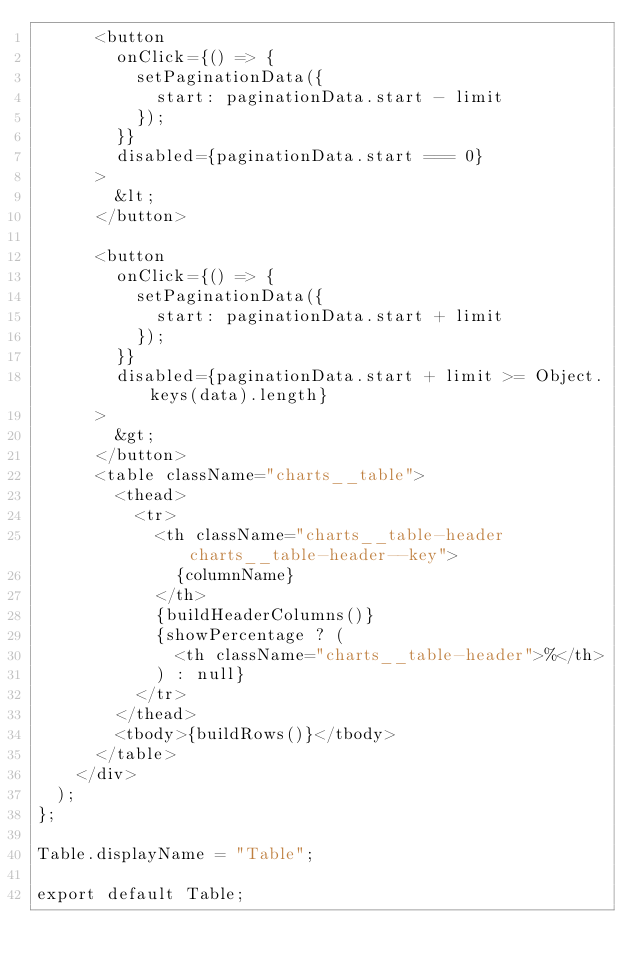Convert code to text. <code><loc_0><loc_0><loc_500><loc_500><_JavaScript_>      <button
        onClick={() => {
          setPaginationData({
            start: paginationData.start - limit
          });
        }}
        disabled={paginationData.start === 0}
      >
        &lt;
      </button>

      <button
        onClick={() => {
          setPaginationData({
            start: paginationData.start + limit
          });
        }}
        disabled={paginationData.start + limit >= Object.keys(data).length}
      >
        &gt;
      </button>
      <table className="charts__table">
        <thead>
          <tr>
            <th className="charts__table-header charts__table-header--key">
              {columnName}
            </th>
            {buildHeaderColumns()}
            {showPercentage ? (
              <th className="charts__table-header">%</th>
            ) : null}
          </tr>
        </thead>
        <tbody>{buildRows()}</tbody>
      </table>
    </div>
  );
};

Table.displayName = "Table";

export default Table;
</code> 